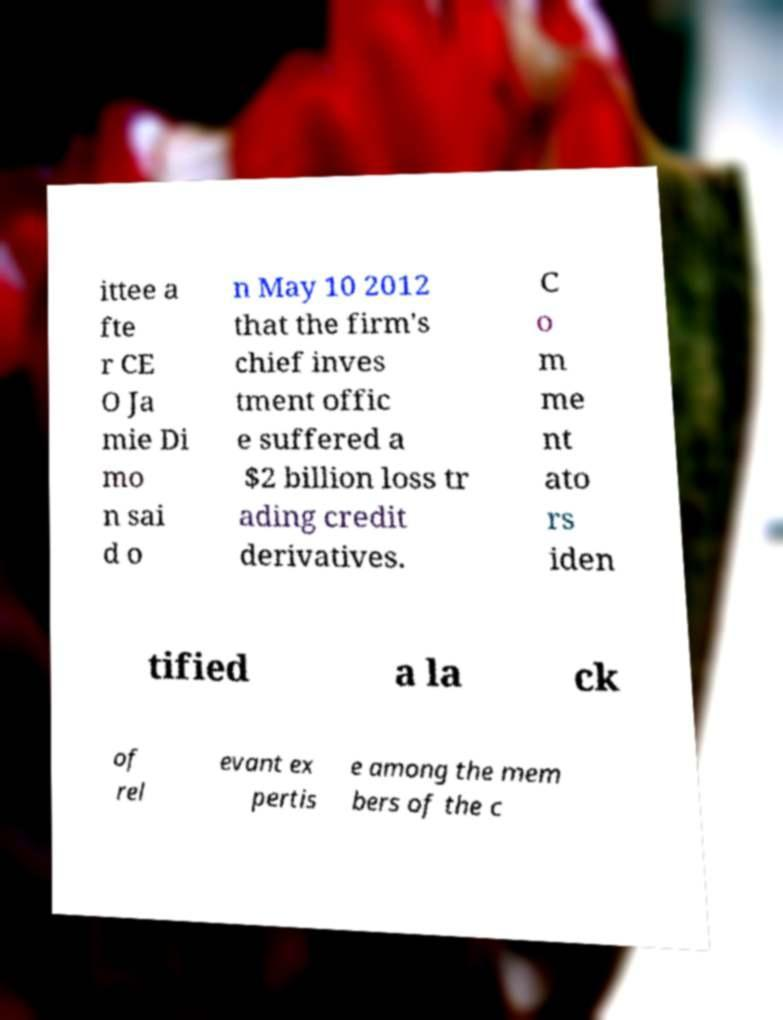Please identify and transcribe the text found in this image. ittee a fte r CE O Ja mie Di mo n sai d o n May 10 2012 that the firm's chief inves tment offic e suffered a $2 billion loss tr ading credit derivatives. C o m me nt ato rs iden tified a la ck of rel evant ex pertis e among the mem bers of the c 